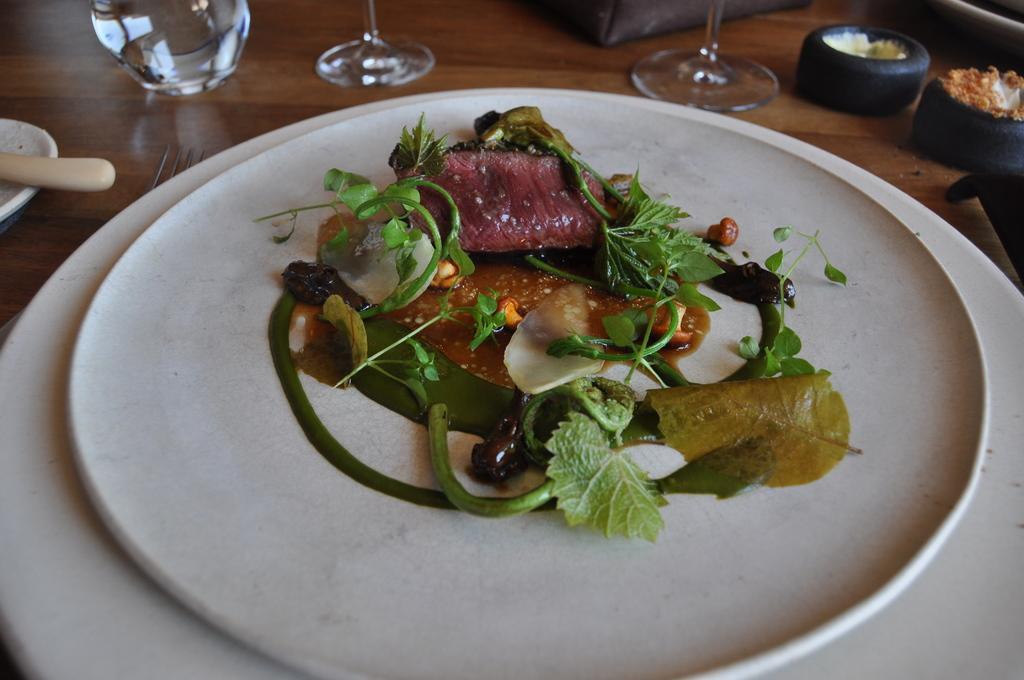Describe this image in one or two sentences. In this image we can see a food item on the plate, there are glasses, and some objects on the table. 